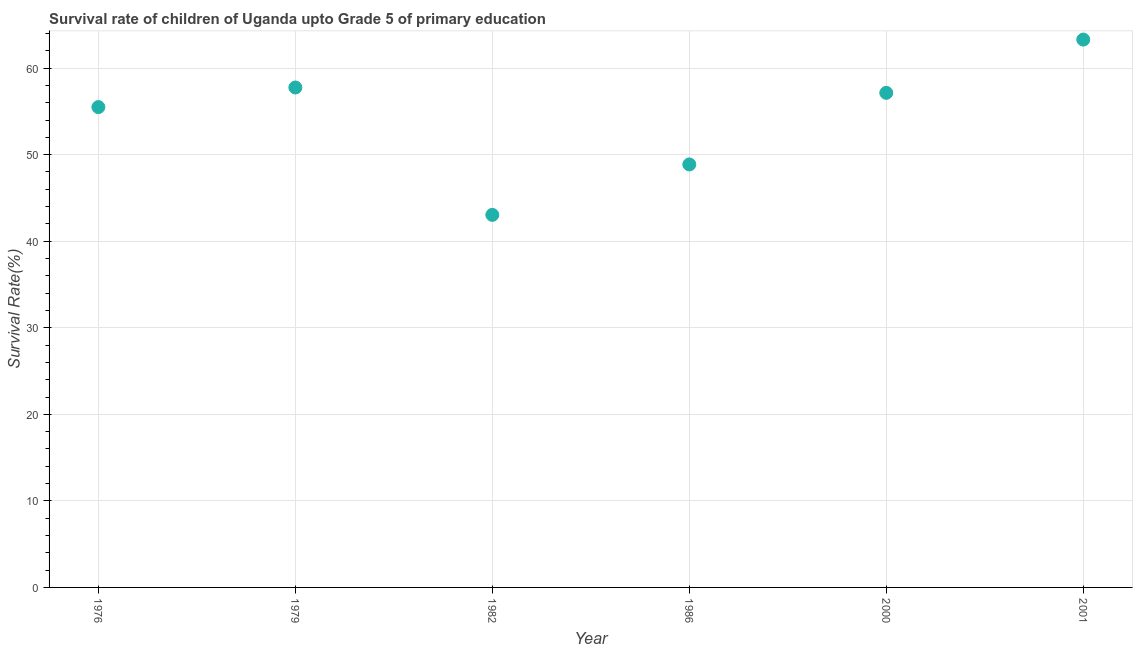What is the survival rate in 2000?
Your answer should be compact. 57.14. Across all years, what is the maximum survival rate?
Provide a succinct answer. 63.29. Across all years, what is the minimum survival rate?
Offer a terse response. 43.04. In which year was the survival rate minimum?
Provide a succinct answer. 1982. What is the sum of the survival rate?
Your response must be concise. 325.6. What is the difference between the survival rate in 1976 and 2001?
Offer a terse response. -7.8. What is the average survival rate per year?
Ensure brevity in your answer.  54.27. What is the median survival rate?
Your answer should be very brief. 56.32. In how many years, is the survival rate greater than 32 %?
Your response must be concise. 6. What is the ratio of the survival rate in 1979 to that in 1982?
Your answer should be very brief. 1.34. Is the difference between the survival rate in 1986 and 2001 greater than the difference between any two years?
Give a very brief answer. No. What is the difference between the highest and the second highest survival rate?
Ensure brevity in your answer.  5.53. Is the sum of the survival rate in 1986 and 2000 greater than the maximum survival rate across all years?
Your answer should be very brief. Yes. What is the difference between the highest and the lowest survival rate?
Your answer should be very brief. 20.25. How many dotlines are there?
Provide a short and direct response. 1. How many years are there in the graph?
Offer a very short reply. 6. Are the values on the major ticks of Y-axis written in scientific E-notation?
Give a very brief answer. No. Does the graph contain grids?
Give a very brief answer. Yes. What is the title of the graph?
Give a very brief answer. Survival rate of children of Uganda upto Grade 5 of primary education. What is the label or title of the X-axis?
Ensure brevity in your answer.  Year. What is the label or title of the Y-axis?
Your response must be concise. Survival Rate(%). What is the Survival Rate(%) in 1976?
Offer a very short reply. 55.5. What is the Survival Rate(%) in 1979?
Offer a very short reply. 57.76. What is the Survival Rate(%) in 1982?
Offer a very short reply. 43.04. What is the Survival Rate(%) in 1986?
Your response must be concise. 48.87. What is the Survival Rate(%) in 2000?
Your answer should be very brief. 57.14. What is the Survival Rate(%) in 2001?
Make the answer very short. 63.29. What is the difference between the Survival Rate(%) in 1976 and 1979?
Your response must be concise. -2.26. What is the difference between the Survival Rate(%) in 1976 and 1982?
Provide a succinct answer. 12.45. What is the difference between the Survival Rate(%) in 1976 and 1986?
Provide a short and direct response. 6.63. What is the difference between the Survival Rate(%) in 1976 and 2000?
Give a very brief answer. -1.64. What is the difference between the Survival Rate(%) in 1976 and 2001?
Ensure brevity in your answer.  -7.8. What is the difference between the Survival Rate(%) in 1979 and 1982?
Give a very brief answer. 14.72. What is the difference between the Survival Rate(%) in 1979 and 1986?
Keep it short and to the point. 8.89. What is the difference between the Survival Rate(%) in 1979 and 2000?
Your answer should be compact. 0.62. What is the difference between the Survival Rate(%) in 1979 and 2001?
Keep it short and to the point. -5.53. What is the difference between the Survival Rate(%) in 1982 and 1986?
Ensure brevity in your answer.  -5.83. What is the difference between the Survival Rate(%) in 1982 and 2000?
Provide a succinct answer. -14.1. What is the difference between the Survival Rate(%) in 1982 and 2001?
Provide a short and direct response. -20.25. What is the difference between the Survival Rate(%) in 1986 and 2000?
Keep it short and to the point. -8.27. What is the difference between the Survival Rate(%) in 1986 and 2001?
Make the answer very short. -14.42. What is the difference between the Survival Rate(%) in 2000 and 2001?
Your answer should be compact. -6.15. What is the ratio of the Survival Rate(%) in 1976 to that in 1979?
Keep it short and to the point. 0.96. What is the ratio of the Survival Rate(%) in 1976 to that in 1982?
Provide a succinct answer. 1.29. What is the ratio of the Survival Rate(%) in 1976 to that in 1986?
Make the answer very short. 1.14. What is the ratio of the Survival Rate(%) in 1976 to that in 2000?
Give a very brief answer. 0.97. What is the ratio of the Survival Rate(%) in 1976 to that in 2001?
Make the answer very short. 0.88. What is the ratio of the Survival Rate(%) in 1979 to that in 1982?
Offer a very short reply. 1.34. What is the ratio of the Survival Rate(%) in 1979 to that in 1986?
Your response must be concise. 1.18. What is the ratio of the Survival Rate(%) in 1979 to that in 2000?
Ensure brevity in your answer.  1.01. What is the ratio of the Survival Rate(%) in 1979 to that in 2001?
Your response must be concise. 0.91. What is the ratio of the Survival Rate(%) in 1982 to that in 1986?
Provide a short and direct response. 0.88. What is the ratio of the Survival Rate(%) in 1982 to that in 2000?
Offer a very short reply. 0.75. What is the ratio of the Survival Rate(%) in 1982 to that in 2001?
Provide a succinct answer. 0.68. What is the ratio of the Survival Rate(%) in 1986 to that in 2000?
Give a very brief answer. 0.85. What is the ratio of the Survival Rate(%) in 1986 to that in 2001?
Provide a short and direct response. 0.77. What is the ratio of the Survival Rate(%) in 2000 to that in 2001?
Make the answer very short. 0.9. 